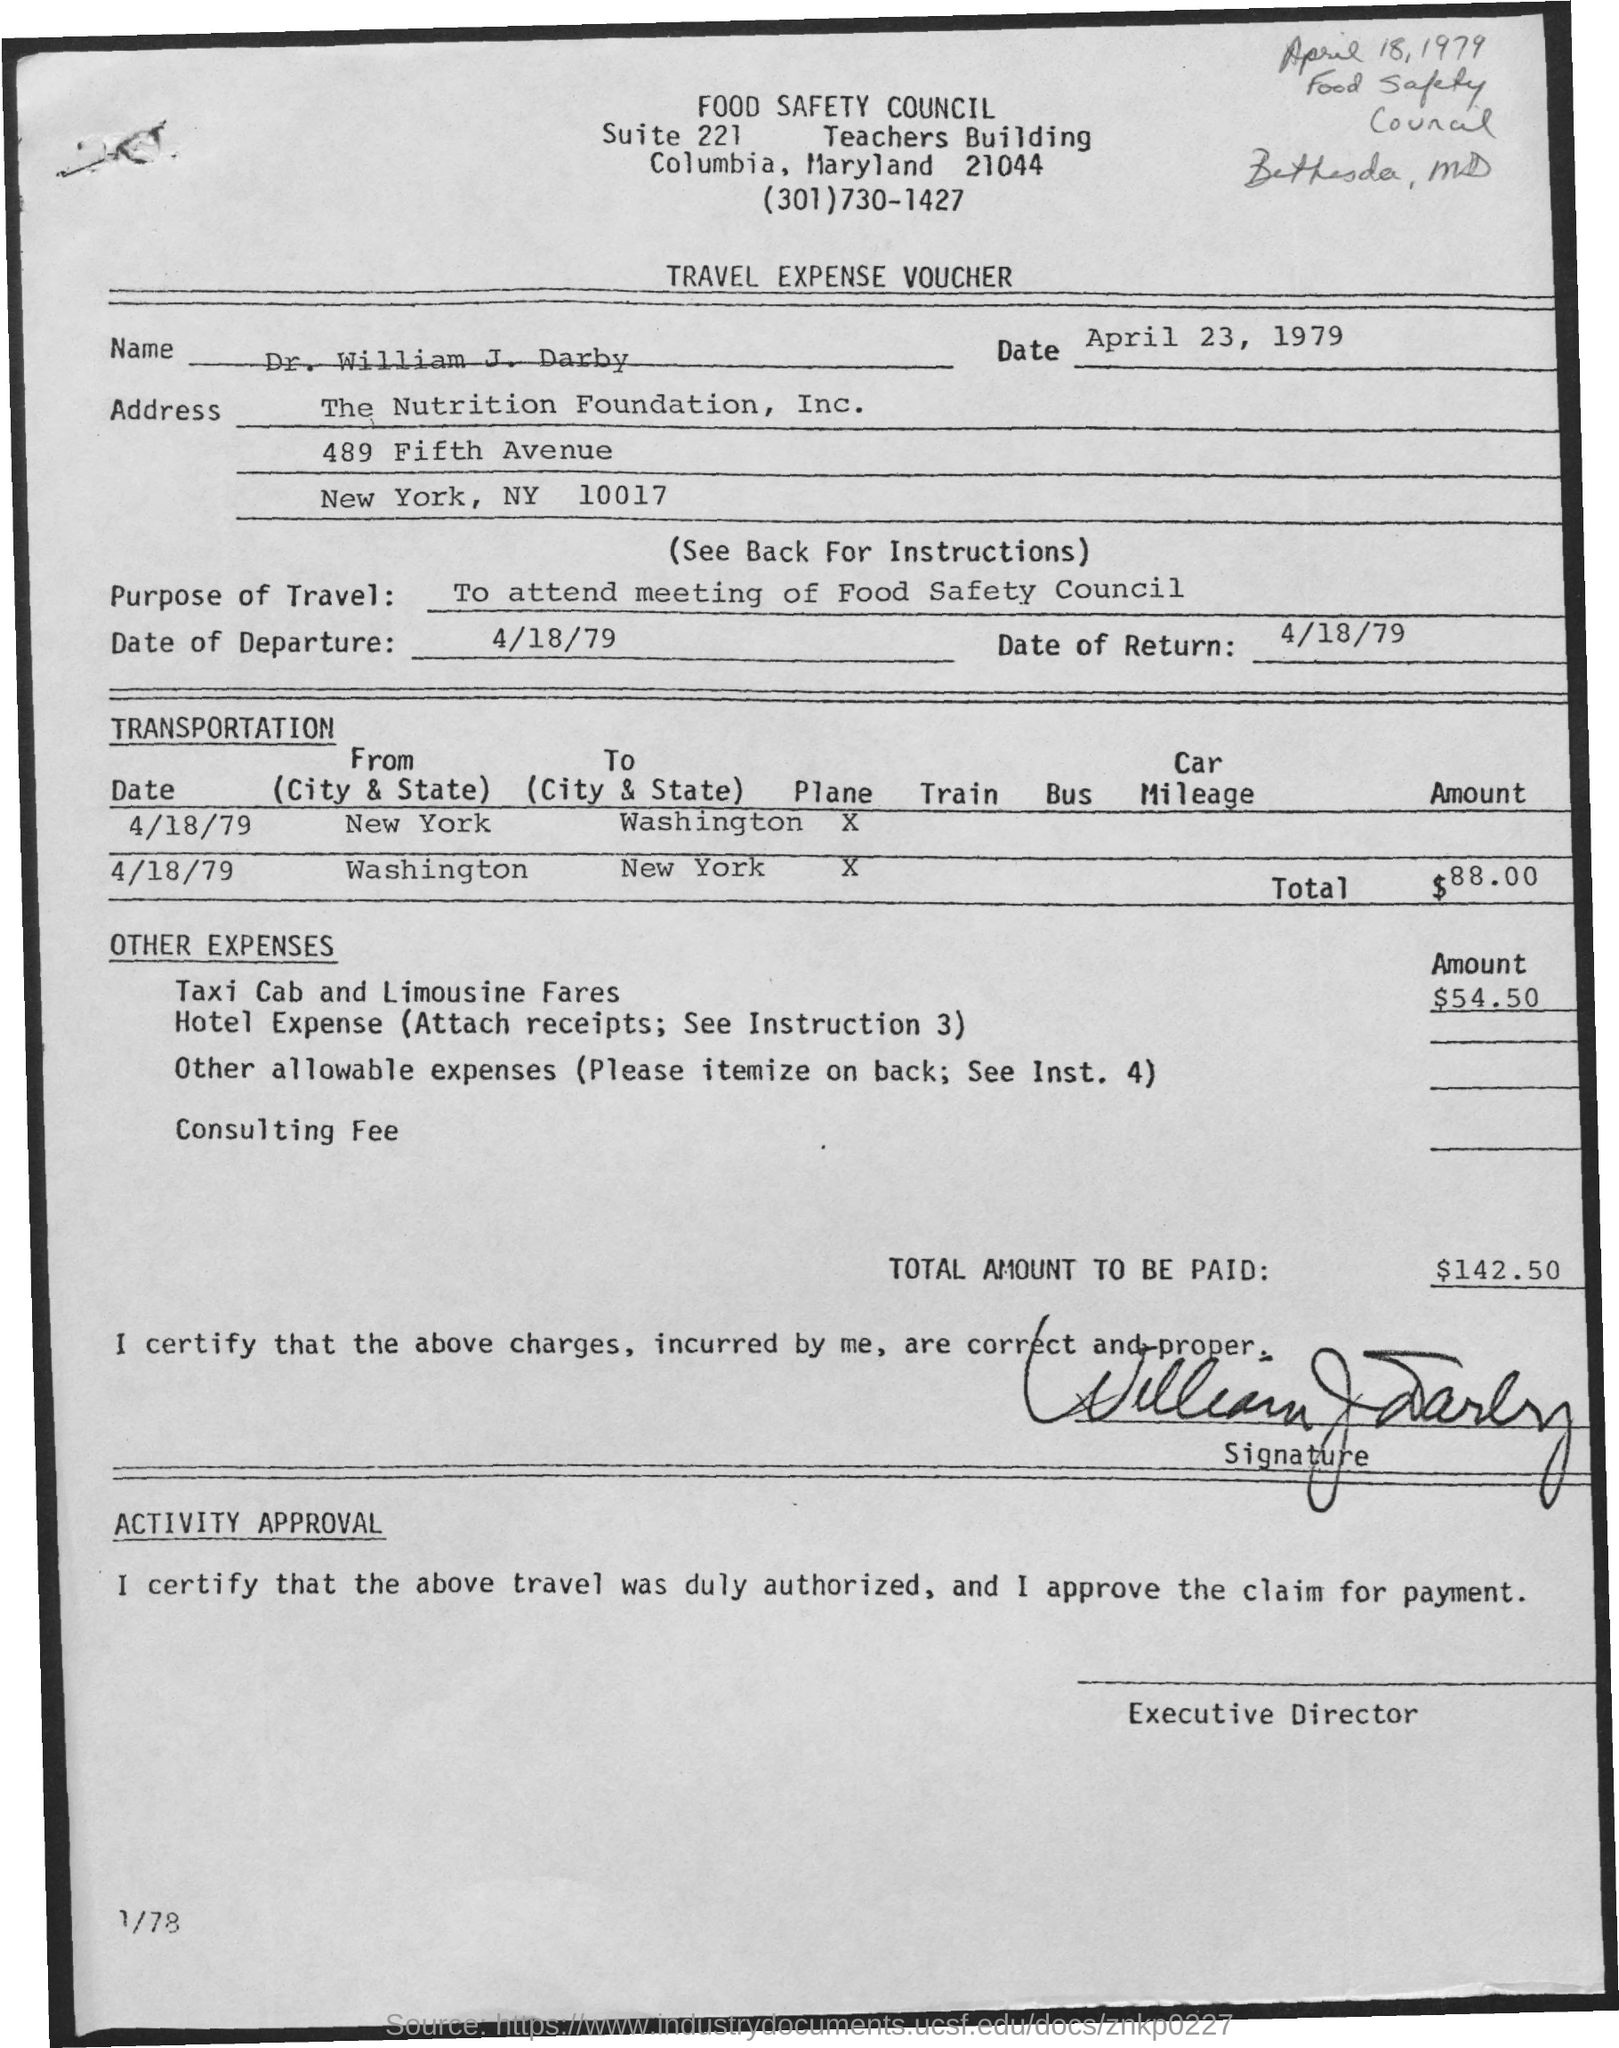What is the name?
Give a very brief answer. Dr. William J. Darby. What is the purpose of travel?
Offer a very short reply. To attend meeting of Food Safety Council. What is the date of departure?
Your answer should be very brief. 4/18/79. What is the date of Return?
Ensure brevity in your answer.  4/18/79. What is the total amount to be paid?
Ensure brevity in your answer.  $142.50. 